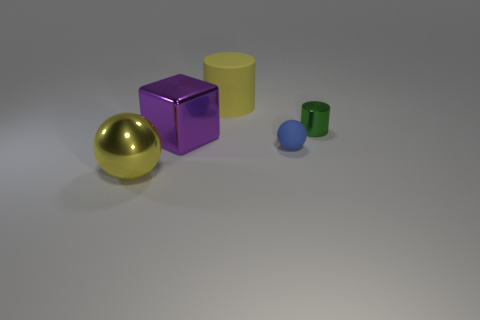Add 3 cyan metallic objects. How many objects exist? 8 Subtract all spheres. How many objects are left? 3 Subtract all brown matte cylinders. Subtract all tiny matte spheres. How many objects are left? 4 Add 2 metal cubes. How many metal cubes are left? 3 Add 4 tiny metal cylinders. How many tiny metal cylinders exist? 5 Subtract 0 green cubes. How many objects are left? 5 